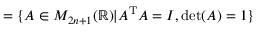Convert formula to latex. <formula><loc_0><loc_0><loc_500><loc_500>= \{ A \in M _ { 2 n + 1 } ( \mathbb { R } ) | A ^ { T } A = I , \det ( A ) = 1 \}</formula> 